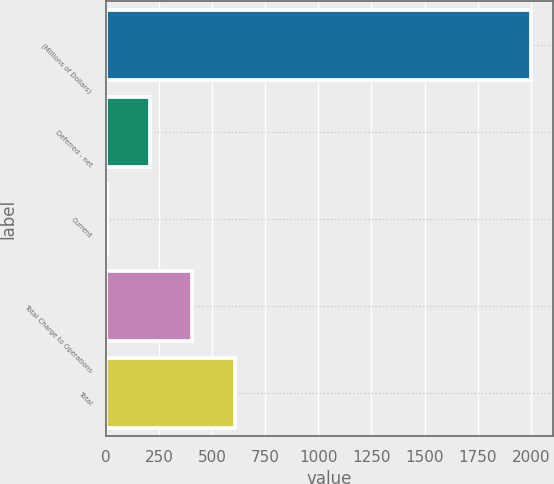Convert chart. <chart><loc_0><loc_0><loc_500><loc_500><bar_chart><fcel>(Millions of Dollars)<fcel>Deferred - net<fcel>Current<fcel>Total Charge to Operations<fcel>Total<nl><fcel>2003<fcel>206.6<fcel>7<fcel>406.2<fcel>605.8<nl></chart> 